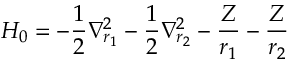Convert formula to latex. <formula><loc_0><loc_0><loc_500><loc_500>H _ { 0 } = - { \frac { 1 } { 2 } } \nabla _ { r _ { 1 } } ^ { 2 } - { \frac { 1 } { 2 } } \nabla _ { r _ { 2 } } ^ { 2 } - { \frac { Z } { r _ { 1 } } } - { \frac { Z } { r _ { 2 } } }</formula> 